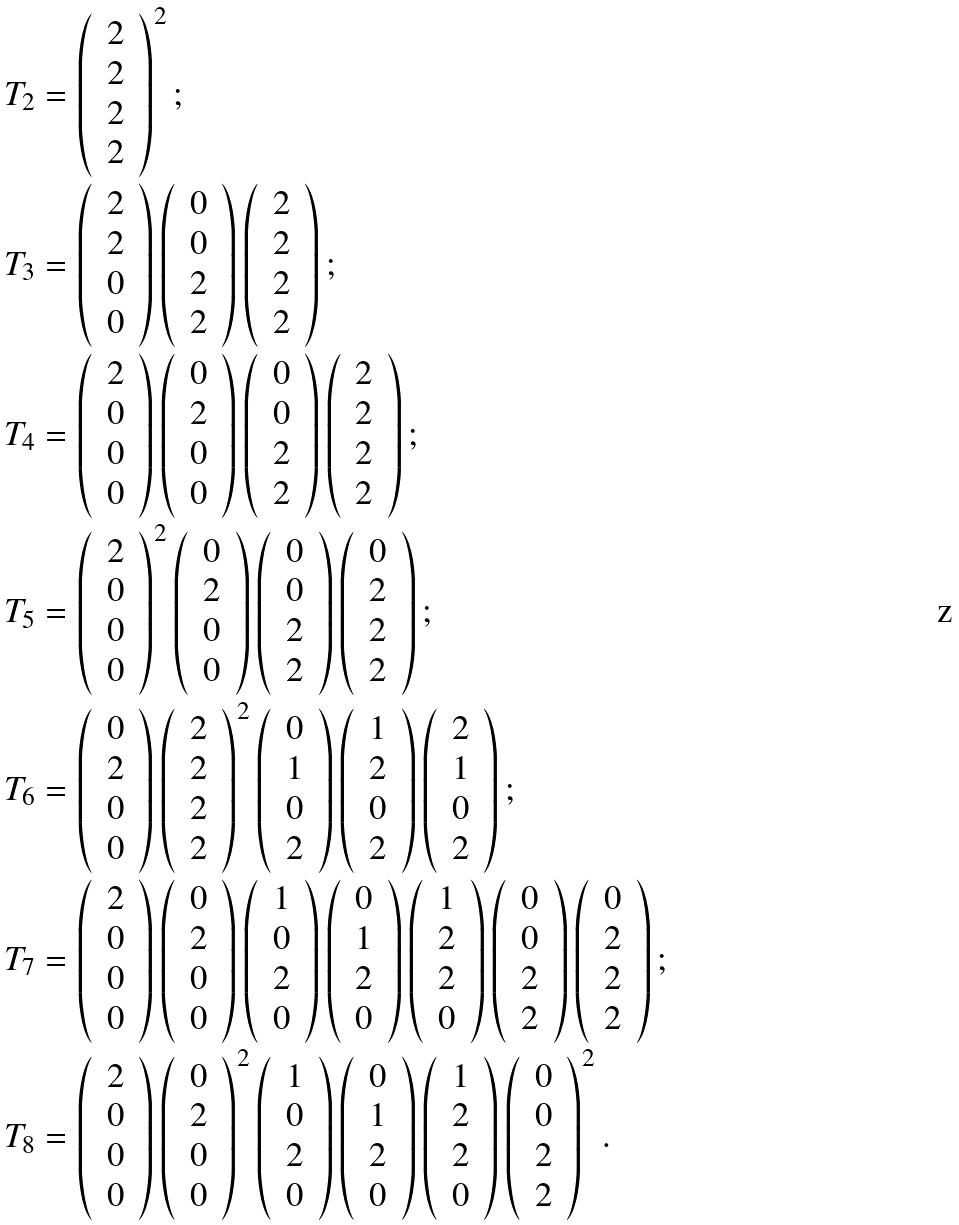Convert formula to latex. <formula><loc_0><loc_0><loc_500><loc_500>& T _ { 2 } = \left ( \, \begin{array} { c } 2 \\ 2 \\ 2 \\ 2 \end{array} \, \right ) ^ { 2 } ; \\ & T _ { 3 } = \left ( \, \begin{array} { c } 2 \\ 2 \\ 0 \\ 0 \end{array} \, \right ) \left ( \, \begin{array} { c } 0 \\ 0 \\ 2 \\ 2 \end{array} \, \right ) \left ( \, \begin{array} { c } 2 \\ 2 \\ 2 \\ 2 \end{array} \, \right ) ; \\ & T _ { 4 } = \left ( \, \begin{array} { c } 2 \\ 0 \\ 0 \\ 0 \end{array} \, \right ) \left ( \, \begin{array} { c } 0 \\ 2 \\ 0 \\ 0 \end{array} \, \right ) \left ( \, \begin{array} { c } 0 \\ 0 \\ 2 \\ 2 \end{array} \, \right ) \left ( \, \begin{array} { c } 2 \\ 2 \\ 2 \\ 2 \end{array} \, \right ) ; \\ & T _ { 5 } = \left ( \, \begin{array} { c } 2 \\ 0 \\ 0 \\ 0 \end{array} \, \right ) ^ { 2 } \left ( \, \begin{array} { c } 0 \\ 2 \\ 0 \\ 0 \end{array} \, \right ) \left ( \, \begin{array} { c } 0 \\ 0 \\ 2 \\ 2 \end{array} \, \right ) \left ( \, \begin{array} { c } 0 \\ 2 \\ 2 \\ 2 \end{array} \, \right ) ; \\ & T _ { 6 } = \left ( \, \begin{array} { c } 0 \\ 2 \\ 0 \\ 0 \end{array} \, \right ) \left ( \, \begin{array} { c } 2 \\ 2 \\ 2 \\ 2 \end{array} \, \right ) ^ { 2 } \left ( \, \begin{array} { c } 0 \\ 1 \\ 0 \\ 2 \end{array} \, \right ) \left ( \, \begin{array} { c } 1 \\ 2 \\ 0 \\ 2 \end{array} \, \right ) \left ( \, \begin{array} { c } 2 \\ 1 \\ 0 \\ 2 \end{array} \, \right ) ; \\ & T _ { 7 } = \left ( \, \begin{array} { c } 2 \\ 0 \\ 0 \\ 0 \end{array} \, \right ) \left ( \, \begin{array} { c } 0 \\ 2 \\ 0 \\ 0 \end{array} \, \right ) \left ( \, \begin{array} { c } 1 \\ 0 \\ 2 \\ 0 \end{array} \, \right ) \left ( \, \begin{array} { c } 0 \\ 1 \\ 2 \\ 0 \end{array} \, \right ) \left ( \, \begin{array} { c } 1 \\ 2 \\ 2 \\ 0 \end{array} \, \right ) \left ( \, \begin{array} { c } 0 \\ 0 \\ 2 \\ 2 \end{array} \, \right ) \left ( \, \begin{array} { c } 0 \\ 2 \\ 2 \\ 2 \end{array} \, \right ) ; \\ & T _ { 8 } = \left ( \, \begin{array} { c } 2 \\ 0 \\ 0 \\ 0 \end{array} \, \right ) \left ( \, \begin{array} { c } 0 \\ 2 \\ 0 \\ 0 \end{array} \, \right ) ^ { 2 } \left ( \, \begin{array} { c } 1 \\ 0 \\ 2 \\ 0 \end{array} \, \right ) \left ( \, \begin{array} { c } 0 \\ 1 \\ 2 \\ 0 \end{array} \, \right ) \left ( \, \begin{array} { c } 1 \\ 2 \\ 2 \\ 0 \end{array} \, \right ) \left ( \, \begin{array} { c } 0 \\ 0 \\ 2 \\ 2 \end{array} \, \right ) ^ { 2 } .</formula> 